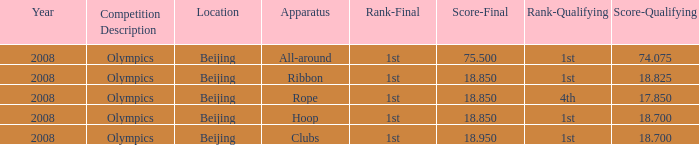What was her final result on the ribbon device? 18.85. Help me parse the entirety of this table. {'header': ['Year', 'Competition Description', 'Location', 'Apparatus', 'Rank-Final', 'Score-Final', 'Rank-Qualifying', 'Score-Qualifying'], 'rows': [['2008', 'Olympics', 'Beijing', 'All-around', '1st', '75.500', '1st', '74.075'], ['2008', 'Olympics', 'Beijing', 'Ribbon', '1st', '18.850', '1st', '18.825'], ['2008', 'Olympics', 'Beijing', 'Rope', '1st', '18.850', '4th', '17.850'], ['2008', 'Olympics', 'Beijing', 'Hoop', '1st', '18.850', '1st', '18.700'], ['2008', 'Olympics', 'Beijing', 'Clubs', '1st', '18.950', '1st', '18.700']]} 